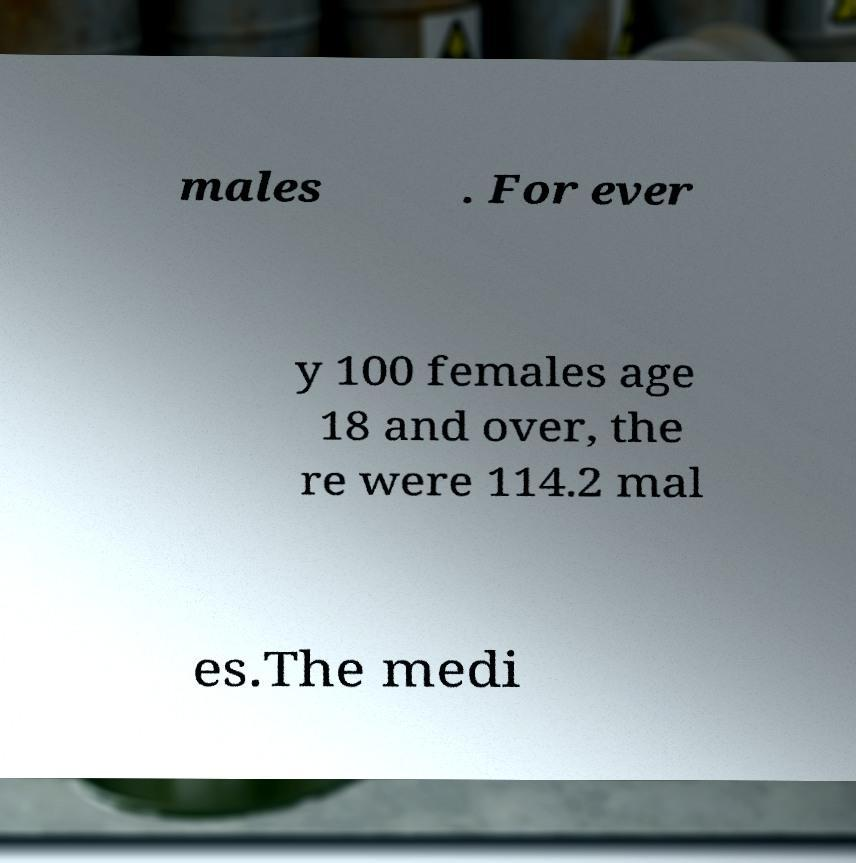For documentation purposes, I need the text within this image transcribed. Could you provide that? males . For ever y 100 females age 18 and over, the re were 114.2 mal es.The medi 